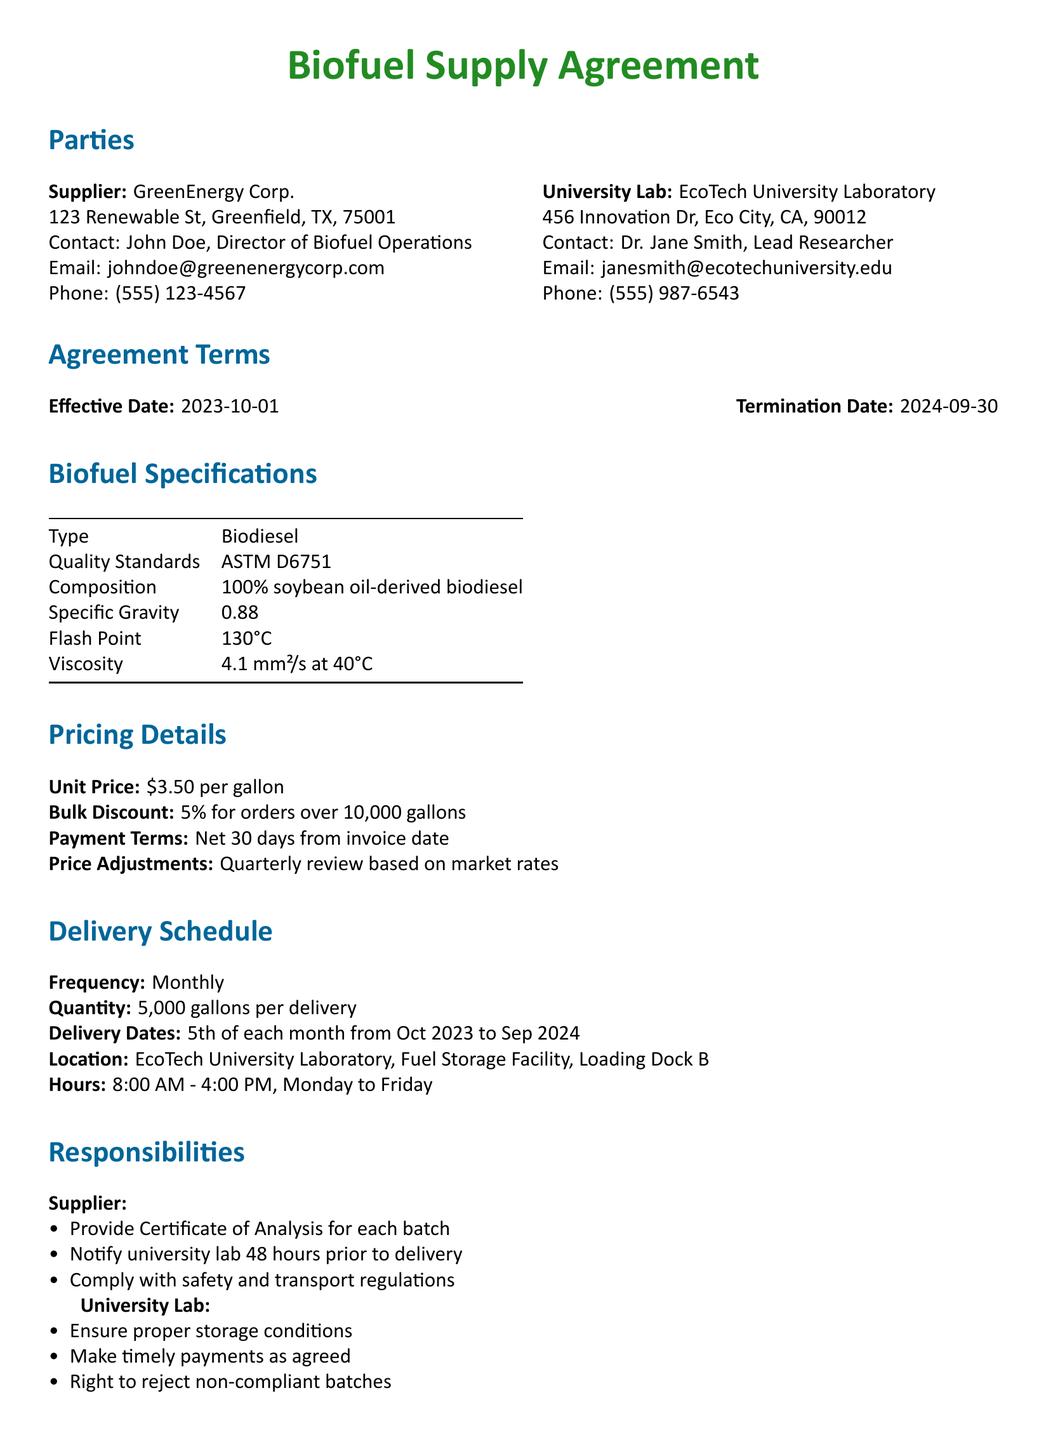What is the effective date of the agreement? The effective date is specified under the Agreement Terms section.
Answer: 2023-10-01 Who is the contact person for the Supplier? The Supplier's contact person is mentioned in the Parties section.
Answer: John Doe What is the unit price of the biodiesel? The unit price is provided in the Pricing Details section.
Answer: $3.50 per gallon What is the frequency of deliveries? The delivery frequency is stated in the Delivery Schedule section.
Answer: Monthly What is the bulk discount percentage? The bulk discount percentage can be found in the Pricing Details section.
Answer: 5% What must the Supplier provide for each batch? This requirement is outlined in the Responsibilities section for the Supplier.
Answer: Certificate of Analysis What are the university lab's working hours for receiving deliveries? The working hours are specified in the Delivery Schedule section.
Answer: 8:00 AM - 4:00 PM, Monday to Friday Where should the deliveries be made? The delivery location is mentioned in the Delivery Schedule section.
Answer: EcoTech University Laboratory, Fuel Storage Facility, Loading Dock B What will happen if disputes cannot be resolved through mediation? The procedure for unresolved disputes is outlined in the Dispute Resolution section.
Answer: Subject to the jurisdiction of the courts in Greenfield, Texas 